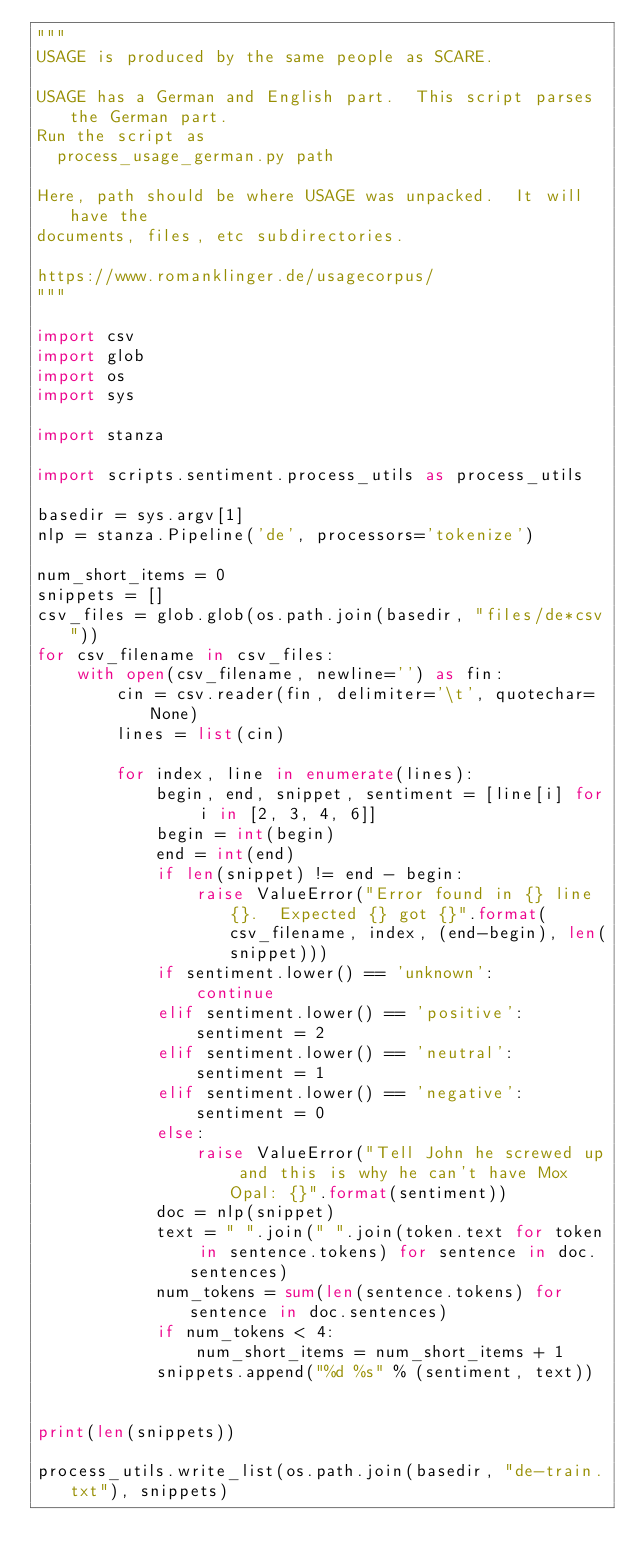Convert code to text. <code><loc_0><loc_0><loc_500><loc_500><_Python_>"""
USAGE is produced by the same people as SCARE.  

USAGE has a German and English part.  This script parses the German part.
Run the script as 
  process_usage_german.py path

Here, path should be where USAGE was unpacked.  It will have the
documents, files, etc subdirectories.

https://www.romanklinger.de/usagecorpus/
"""

import csv
import glob
import os
import sys

import stanza

import scripts.sentiment.process_utils as process_utils

basedir = sys.argv[1]
nlp = stanza.Pipeline('de', processors='tokenize')

num_short_items = 0
snippets = []
csv_files = glob.glob(os.path.join(basedir, "files/de*csv"))
for csv_filename in csv_files:
    with open(csv_filename, newline='') as fin:
        cin = csv.reader(fin, delimiter='\t', quotechar=None)
        lines = list(cin)

        for index, line in enumerate(lines):
            begin, end, snippet, sentiment = [line[i] for i in [2, 3, 4, 6]]
            begin = int(begin)
            end = int(end)
            if len(snippet) != end - begin:
                raise ValueError("Error found in {} line {}.  Expected {} got {}".format(csv_filename, index, (end-begin), len(snippet)))
            if sentiment.lower() == 'unknown':
                continue
            elif sentiment.lower() == 'positive':
                sentiment = 2
            elif sentiment.lower() == 'neutral':
                sentiment = 1
            elif sentiment.lower() == 'negative':
                sentiment = 0
            else:
                raise ValueError("Tell John he screwed up and this is why he can't have Mox Opal: {}".format(sentiment))
            doc = nlp(snippet)
            text = " ".join(" ".join(token.text for token in sentence.tokens) for sentence in doc.sentences)
            num_tokens = sum(len(sentence.tokens) for sentence in doc.sentences)
            if num_tokens < 4:
                num_short_items = num_short_items + 1
            snippets.append("%d %s" % (sentiment, text))


print(len(snippets))

process_utils.write_list(os.path.join(basedir, "de-train.txt"), snippets)

</code> 